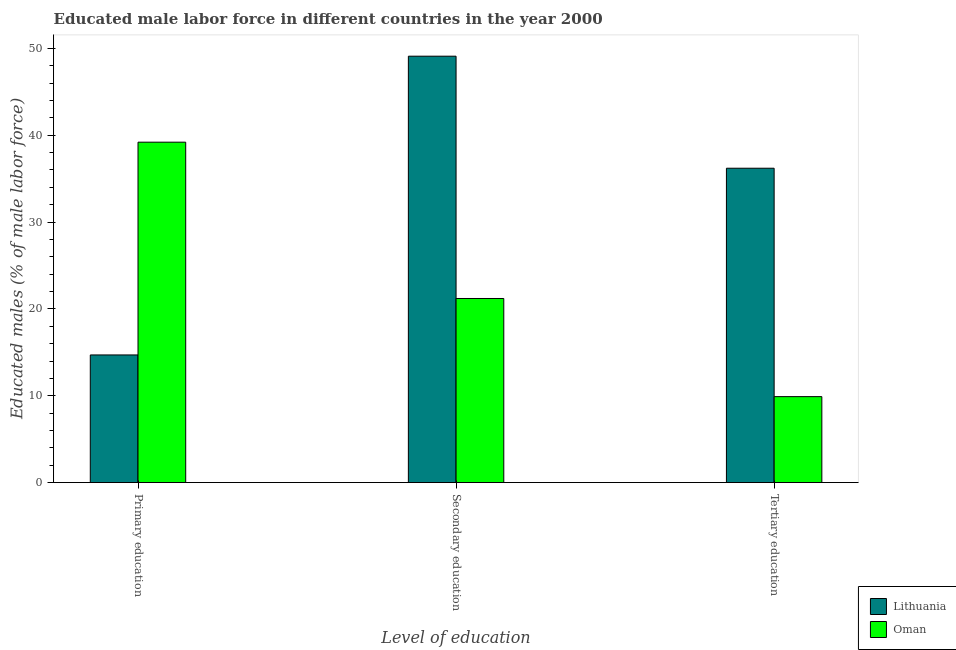How many different coloured bars are there?
Your answer should be compact. 2. How many groups of bars are there?
Provide a succinct answer. 3. Are the number of bars on each tick of the X-axis equal?
Provide a short and direct response. Yes. How many bars are there on the 1st tick from the right?
Provide a short and direct response. 2. What is the label of the 2nd group of bars from the left?
Offer a very short reply. Secondary education. What is the percentage of male labor force who received primary education in Lithuania?
Give a very brief answer. 14.7. Across all countries, what is the maximum percentage of male labor force who received secondary education?
Offer a very short reply. 49.1. Across all countries, what is the minimum percentage of male labor force who received tertiary education?
Your answer should be compact. 9.9. In which country was the percentage of male labor force who received primary education maximum?
Your response must be concise. Oman. In which country was the percentage of male labor force who received primary education minimum?
Make the answer very short. Lithuania. What is the total percentage of male labor force who received secondary education in the graph?
Keep it short and to the point. 70.3. What is the difference between the percentage of male labor force who received primary education in Oman and that in Lithuania?
Make the answer very short. 24.5. What is the average percentage of male labor force who received tertiary education per country?
Make the answer very short. 23.05. What is the difference between the percentage of male labor force who received primary education and percentage of male labor force who received secondary education in Oman?
Your answer should be very brief. 18. In how many countries, is the percentage of male labor force who received secondary education greater than 2 %?
Make the answer very short. 2. What is the ratio of the percentage of male labor force who received tertiary education in Lithuania to that in Oman?
Keep it short and to the point. 3.66. Is the difference between the percentage of male labor force who received tertiary education in Lithuania and Oman greater than the difference between the percentage of male labor force who received primary education in Lithuania and Oman?
Keep it short and to the point. Yes. What is the difference between the highest and the second highest percentage of male labor force who received tertiary education?
Provide a short and direct response. 26.3. What is the difference between the highest and the lowest percentage of male labor force who received secondary education?
Offer a terse response. 27.9. Is the sum of the percentage of male labor force who received primary education in Lithuania and Oman greater than the maximum percentage of male labor force who received tertiary education across all countries?
Ensure brevity in your answer.  Yes. What does the 2nd bar from the left in Tertiary education represents?
Provide a short and direct response. Oman. What does the 2nd bar from the right in Secondary education represents?
Give a very brief answer. Lithuania. Is it the case that in every country, the sum of the percentage of male labor force who received primary education and percentage of male labor force who received secondary education is greater than the percentage of male labor force who received tertiary education?
Make the answer very short. Yes. How many bars are there?
Offer a terse response. 6. Are all the bars in the graph horizontal?
Provide a short and direct response. No. Does the graph contain any zero values?
Offer a very short reply. No. Where does the legend appear in the graph?
Offer a very short reply. Bottom right. What is the title of the graph?
Offer a very short reply. Educated male labor force in different countries in the year 2000. What is the label or title of the X-axis?
Provide a short and direct response. Level of education. What is the label or title of the Y-axis?
Your response must be concise. Educated males (% of male labor force). What is the Educated males (% of male labor force) of Lithuania in Primary education?
Provide a succinct answer. 14.7. What is the Educated males (% of male labor force) of Oman in Primary education?
Offer a very short reply. 39.2. What is the Educated males (% of male labor force) in Lithuania in Secondary education?
Provide a succinct answer. 49.1. What is the Educated males (% of male labor force) in Oman in Secondary education?
Keep it short and to the point. 21.2. What is the Educated males (% of male labor force) of Lithuania in Tertiary education?
Your answer should be compact. 36.2. What is the Educated males (% of male labor force) in Oman in Tertiary education?
Make the answer very short. 9.9. Across all Level of education, what is the maximum Educated males (% of male labor force) of Lithuania?
Keep it short and to the point. 49.1. Across all Level of education, what is the maximum Educated males (% of male labor force) of Oman?
Keep it short and to the point. 39.2. Across all Level of education, what is the minimum Educated males (% of male labor force) of Lithuania?
Provide a succinct answer. 14.7. Across all Level of education, what is the minimum Educated males (% of male labor force) of Oman?
Offer a very short reply. 9.9. What is the total Educated males (% of male labor force) in Lithuania in the graph?
Offer a terse response. 100. What is the total Educated males (% of male labor force) in Oman in the graph?
Offer a terse response. 70.3. What is the difference between the Educated males (% of male labor force) of Lithuania in Primary education and that in Secondary education?
Provide a short and direct response. -34.4. What is the difference between the Educated males (% of male labor force) in Lithuania in Primary education and that in Tertiary education?
Provide a short and direct response. -21.5. What is the difference between the Educated males (% of male labor force) in Oman in Primary education and that in Tertiary education?
Offer a very short reply. 29.3. What is the difference between the Educated males (% of male labor force) in Lithuania in Secondary education and that in Tertiary education?
Provide a succinct answer. 12.9. What is the difference between the Educated males (% of male labor force) in Oman in Secondary education and that in Tertiary education?
Your answer should be compact. 11.3. What is the difference between the Educated males (% of male labor force) of Lithuania in Primary education and the Educated males (% of male labor force) of Oman in Secondary education?
Your answer should be compact. -6.5. What is the difference between the Educated males (% of male labor force) of Lithuania in Primary education and the Educated males (% of male labor force) of Oman in Tertiary education?
Your answer should be very brief. 4.8. What is the difference between the Educated males (% of male labor force) of Lithuania in Secondary education and the Educated males (% of male labor force) of Oman in Tertiary education?
Provide a short and direct response. 39.2. What is the average Educated males (% of male labor force) of Lithuania per Level of education?
Your answer should be very brief. 33.33. What is the average Educated males (% of male labor force) of Oman per Level of education?
Ensure brevity in your answer.  23.43. What is the difference between the Educated males (% of male labor force) in Lithuania and Educated males (% of male labor force) in Oman in Primary education?
Your response must be concise. -24.5. What is the difference between the Educated males (% of male labor force) in Lithuania and Educated males (% of male labor force) in Oman in Secondary education?
Offer a terse response. 27.9. What is the difference between the Educated males (% of male labor force) of Lithuania and Educated males (% of male labor force) of Oman in Tertiary education?
Provide a succinct answer. 26.3. What is the ratio of the Educated males (% of male labor force) in Lithuania in Primary education to that in Secondary education?
Your answer should be compact. 0.3. What is the ratio of the Educated males (% of male labor force) in Oman in Primary education to that in Secondary education?
Make the answer very short. 1.85. What is the ratio of the Educated males (% of male labor force) of Lithuania in Primary education to that in Tertiary education?
Your answer should be very brief. 0.41. What is the ratio of the Educated males (% of male labor force) of Oman in Primary education to that in Tertiary education?
Your answer should be very brief. 3.96. What is the ratio of the Educated males (% of male labor force) of Lithuania in Secondary education to that in Tertiary education?
Your answer should be compact. 1.36. What is the ratio of the Educated males (% of male labor force) of Oman in Secondary education to that in Tertiary education?
Provide a short and direct response. 2.14. What is the difference between the highest and the lowest Educated males (% of male labor force) of Lithuania?
Provide a succinct answer. 34.4. What is the difference between the highest and the lowest Educated males (% of male labor force) in Oman?
Offer a terse response. 29.3. 